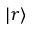Convert formula to latex. <formula><loc_0><loc_0><loc_500><loc_500>| r \rangle</formula> 